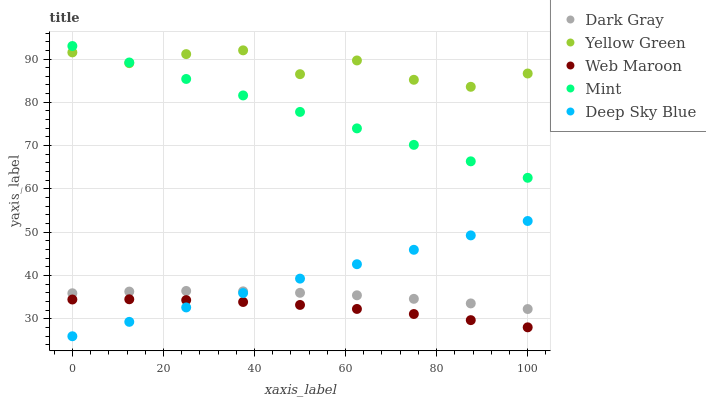Does Web Maroon have the minimum area under the curve?
Answer yes or no. Yes. Does Yellow Green have the maximum area under the curve?
Answer yes or no. Yes. Does Mint have the minimum area under the curve?
Answer yes or no. No. Does Mint have the maximum area under the curve?
Answer yes or no. No. Is Deep Sky Blue the smoothest?
Answer yes or no. Yes. Is Yellow Green the roughest?
Answer yes or no. Yes. Is Mint the smoothest?
Answer yes or no. No. Is Mint the roughest?
Answer yes or no. No. Does Deep Sky Blue have the lowest value?
Answer yes or no. Yes. Does Mint have the lowest value?
Answer yes or no. No. Does Mint have the highest value?
Answer yes or no. Yes. Does Web Maroon have the highest value?
Answer yes or no. No. Is Web Maroon less than Dark Gray?
Answer yes or no. Yes. Is Dark Gray greater than Web Maroon?
Answer yes or no. Yes. Does Dark Gray intersect Deep Sky Blue?
Answer yes or no. Yes. Is Dark Gray less than Deep Sky Blue?
Answer yes or no. No. Is Dark Gray greater than Deep Sky Blue?
Answer yes or no. No. Does Web Maroon intersect Dark Gray?
Answer yes or no. No. 